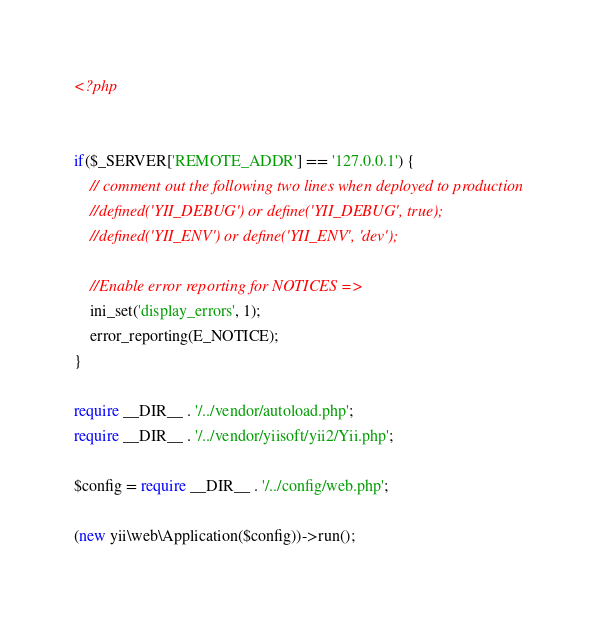<code> <loc_0><loc_0><loc_500><loc_500><_PHP_><?php


if($_SERVER['REMOTE_ADDR'] == '127.0.0.1') {
    // comment out the following two lines when deployed to production
    //defined('YII_DEBUG') or define('YII_DEBUG', true);
    //defined('YII_ENV') or define('YII_ENV', 'dev');
	
	//Enable error reporting for NOTICES => 	 
    ini_set('display_errors', 1);  
    error_reporting(E_NOTICE);
}

require __DIR__ . '/../vendor/autoload.php';
require __DIR__ . '/../vendor/yiisoft/yii2/Yii.php';

$config = require __DIR__ . '/../config/web.php';

(new yii\web\Application($config))->run();
</code> 